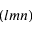<formula> <loc_0><loc_0><loc_500><loc_500>( l m n )</formula> 